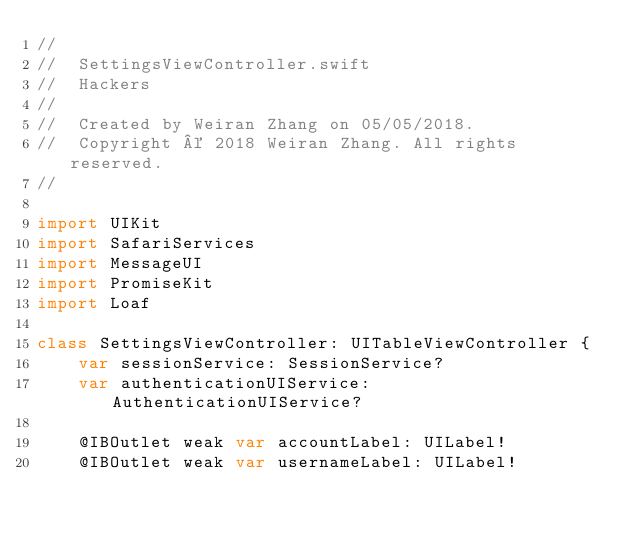Convert code to text. <code><loc_0><loc_0><loc_500><loc_500><_Swift_>//
//  SettingsViewController.swift
//  Hackers
//
//  Created by Weiran Zhang on 05/05/2018.
//  Copyright © 2018 Weiran Zhang. All rights reserved.
//

import UIKit
import SafariServices
import MessageUI
import PromiseKit
import Loaf

class SettingsViewController: UITableViewController {
    var sessionService: SessionService?
    var authenticationUIService: AuthenticationUIService?

    @IBOutlet weak var accountLabel: UILabel!
    @IBOutlet weak var usernameLabel: UILabel!</code> 